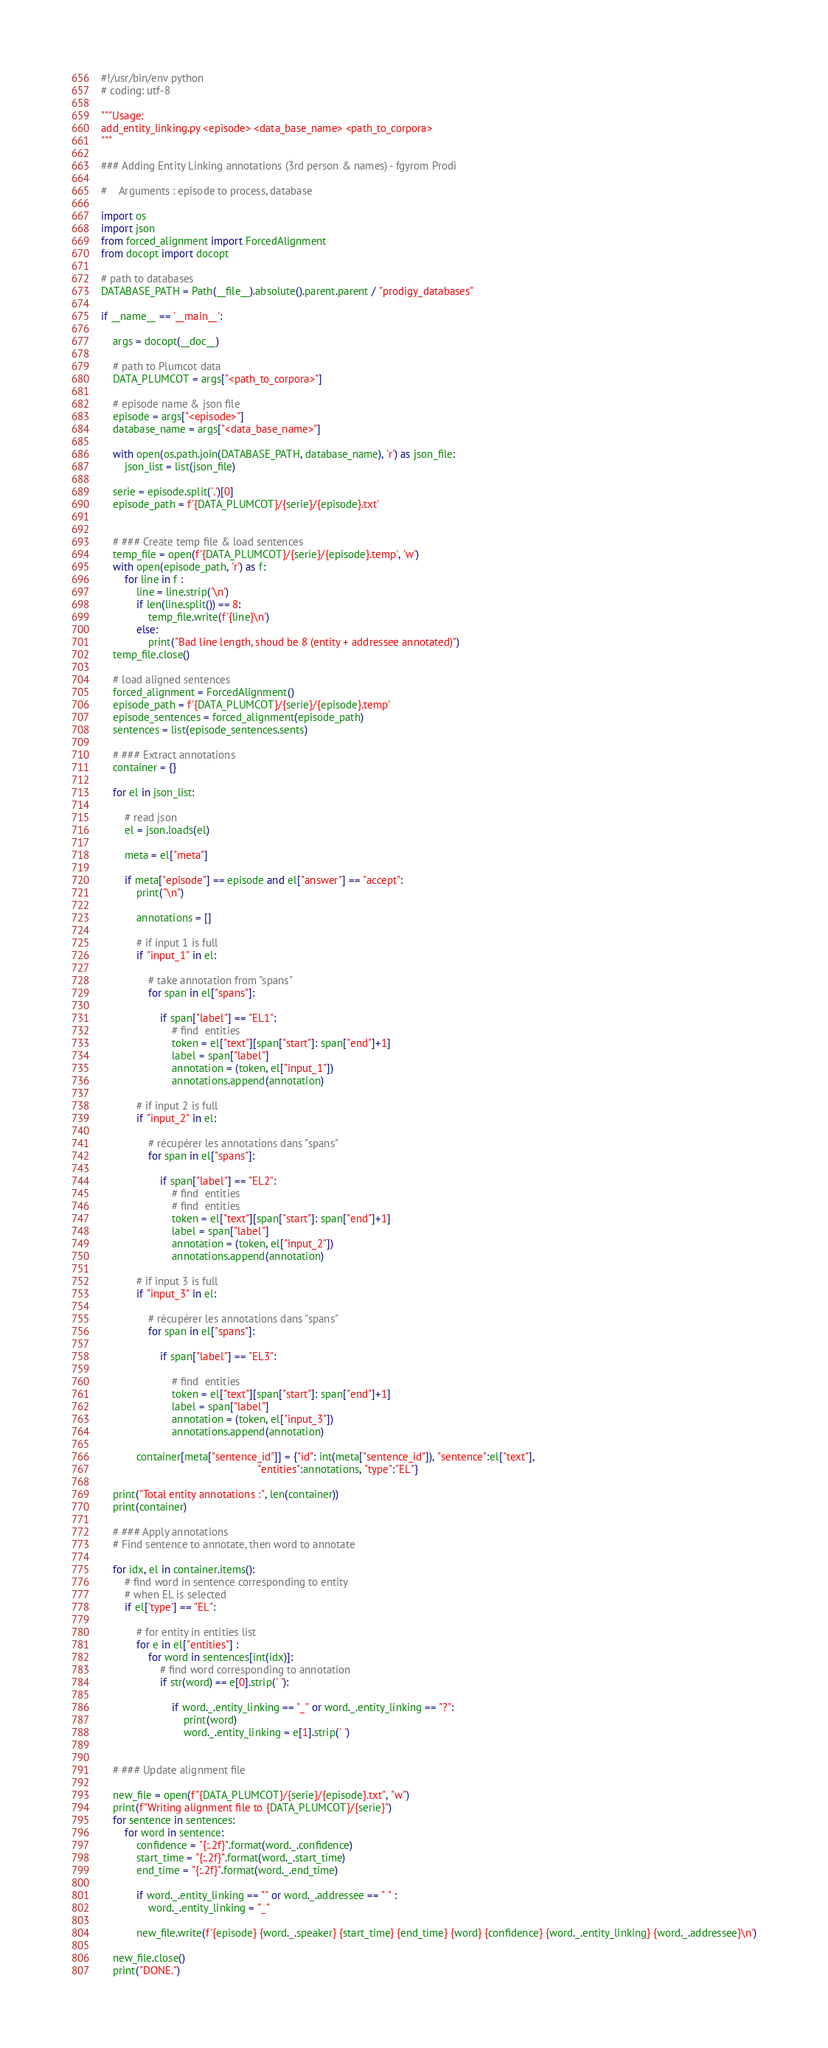<code> <loc_0><loc_0><loc_500><loc_500><_Python_>#!/usr/bin/env python
# coding: utf-8

"""Usage:
add_entity_linking.py <episode> <data_base_name> <path_to_corpora>
"""

### Adding Entity Linking annotations (3rd person & names) - fgyrom Prodi

#    Arguments : episode to process, database 

import os
import json
from forced_alignment import ForcedAlignment
from docopt import docopt

# path to databases
DATABASE_PATH = Path(__file__).absolute().parent.parent / "prodigy_databases"

if __name__ == '__main__':
    
    args = docopt(__doc__)
    
    # path to Plumcot data
    DATA_PLUMCOT = args["<path_to_corpora>"]
    
    # episode name & json file
    episode = args["<episode>"]
    database_name = args["<data_base_name>"]

    with open(os.path.join(DATABASE_PATH, database_name), 'r') as json_file:
        json_list = list(json_file)

    serie = episode.split('.')[0]
    episode_path = f'{DATA_PLUMCOT}/{serie}/{episode}.txt'


    # ### Create temp file & load sentences
    temp_file = open(f'{DATA_PLUMCOT}/{serie}/{episode}.temp', 'w')
    with open(episode_path, 'r') as f:
        for line in f :
            line = line.strip('\n')
            if len(line.split()) == 8:
                temp_file.write(f'{line}\n')
            else:
                print("Bad line length, shoud be 8 (entity + addressee annotated)")
    temp_file.close()

    # load aligned sentences
    forced_alignment = ForcedAlignment()
    episode_path = f'{DATA_PLUMCOT}/{serie}/{episode}.temp'
    episode_sentences = forced_alignment(episode_path)
    sentences = list(episode_sentences.sents)

    # ### Extract annotations
    container = {}

    for el in json_list:

        # read json
        el = json.loads(el)

        meta = el["meta"]

        if meta["episode"] == episode and el["answer"] == "accept":
            print("\n")

            annotations = []

            # if input 1 is full
            if "input_1" in el:

                # take annotation from "spans"
                for span in el["spans"]:

                    if span["label"] == "EL1":
                        # find  entities
                        token = el["text"][span["start"]: span["end"]+1]
                        label = span["label"]
                        annotation = (token, el["input_1"])
                        annotations.append(annotation)

            # if input 2 is full
            if "input_2" in el:

                # récupérer les annotations dans "spans"
                for span in el["spans"]:

                    if span["label"] == "EL2":
                        # find  entities
                        # find  entities
                        token = el["text"][span["start"]: span["end"]+1]
                        label = span["label"]
                        annotation = (token, el["input_2"])
                        annotations.append(annotation)

            # if input 3 is full
            if "input_3" in el:

                # récupérer les annotations dans "spans"
                for span in el["spans"]:

                    if span["label"] == "EL3":

                        # find  entities
                        token = el["text"][span["start"]: span["end"]+1]
                        label = span["label"]
                        annotation = (token, el["input_3"])
                        annotations.append(annotation)

            container[meta["sentence_id"]] = {"id": int(meta["sentence_id"]), "sentence":el["text"], 
                                                     "entities":annotations, "type":"EL"}

    print("Total entity annotations :", len(container))
    print(container)

    # ### Apply annotations
    # Find sentence to annotate, then word to annotate

    for idx, el in container.items():
        # find word in sentence corresponding to entity
        # when EL is selected
        if el['type'] == "EL":

            # for entity in entities list
            for e in el["entities"] :
                for word in sentences[int(idx)]:
                    # find word corresponding to annotation
                    if str(word) == e[0].strip(' '):

                        if word._.entity_linking == "_" or word._.entity_linking == "?":
                            print(word)
                            word._.entity_linking = e[1].strip(' ')


    # ### Update alignment file

    new_file = open(f"{DATA_PLUMCOT}/{serie}/{episode}.txt", "w")
    print(f"Writing alignment file to {DATA_PLUMCOT}/{serie}")
    for sentence in sentences:
        for word in sentence:
            confidence = "{:.2f}".format(word._.confidence)
            start_time = "{:.2f}".format(word._.start_time)
            end_time = "{:.2f}".format(word._.end_time)
            
            if word._.entity_linking == "" or word._.addressee == " " :
                word._.entity_linking = "_"
                
            new_file.write(f'{episode} {word._.speaker} {start_time} {end_time} {word} {confidence} {word._.entity_linking} {word._.addressee}\n')

    new_file.close()
    print("DONE.")





</code> 